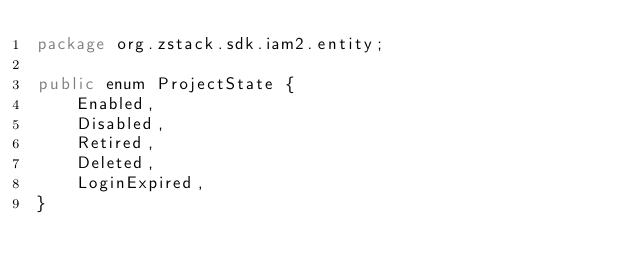<code> <loc_0><loc_0><loc_500><loc_500><_Java_>package org.zstack.sdk.iam2.entity;

public enum ProjectState {
	Enabled,
	Disabled,
	Retired,
	Deleted,
	LoginExpired,
}
</code> 